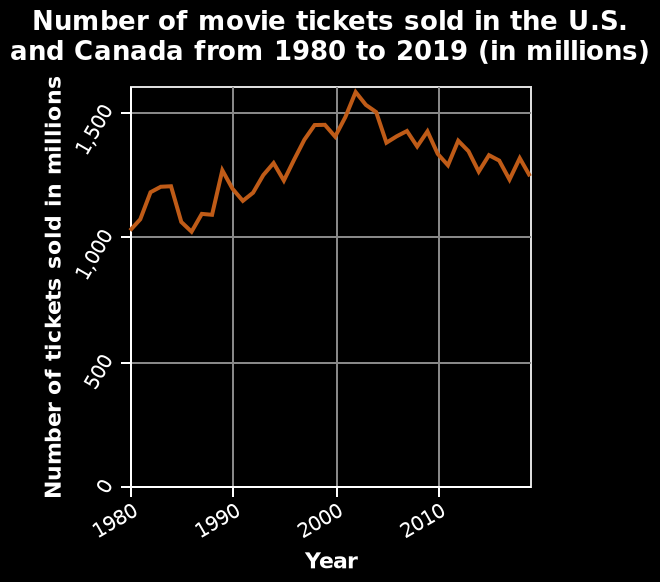<image>
What was the general trend in movie tickets bought between 1980 and 2000?  The general trend was an increase in movie tickets bought. In which region were the movie ticket sales recorded? The movie ticket sales were recorded in the U.S. and Canada. Offer a thorough analysis of the image. The number of movie tickets sold in the US and Canada has never fallen below 1,000 million between 1980-2019. The highest point was above 1,500 million between 2000-2010. Most years between 1980-2019, the figure has fluctuated between 1,000 million and 1,500 million. 